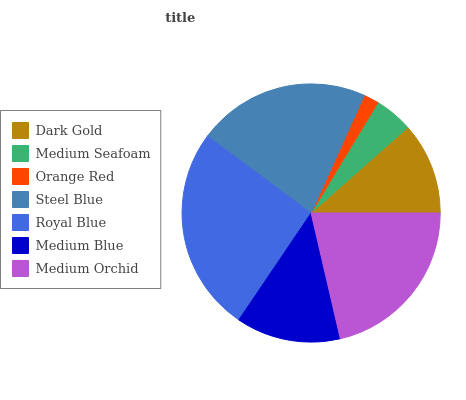Is Orange Red the minimum?
Answer yes or no. Yes. Is Royal Blue the maximum?
Answer yes or no. Yes. Is Medium Seafoam the minimum?
Answer yes or no. No. Is Medium Seafoam the maximum?
Answer yes or no. No. Is Dark Gold greater than Medium Seafoam?
Answer yes or no. Yes. Is Medium Seafoam less than Dark Gold?
Answer yes or no. Yes. Is Medium Seafoam greater than Dark Gold?
Answer yes or no. No. Is Dark Gold less than Medium Seafoam?
Answer yes or no. No. Is Medium Blue the high median?
Answer yes or no. Yes. Is Medium Blue the low median?
Answer yes or no. Yes. Is Royal Blue the high median?
Answer yes or no. No. Is Steel Blue the low median?
Answer yes or no. No. 